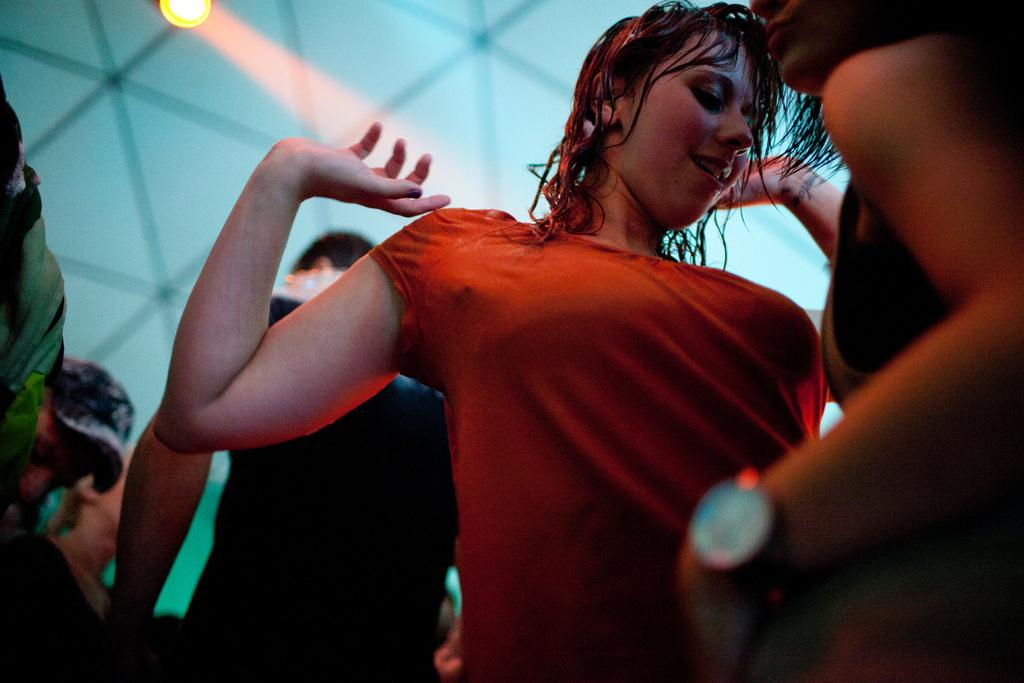Who or what is present in the image? There are people in the image. What are the people doing in the image? The people appear to be dancing. What can be seen in the background of the image? There is a wall in the background of the image. What is the source of light in the image? There is a light visible at the top of the image. How much money is being exchanged between the dancers in the image? There is no indication of money being exchanged in the image; the people are simply dancing. What type of iron is being used to press the dancers' clothes in the image? There is no iron present in the image, and the people are not shown pressing their clothes. 